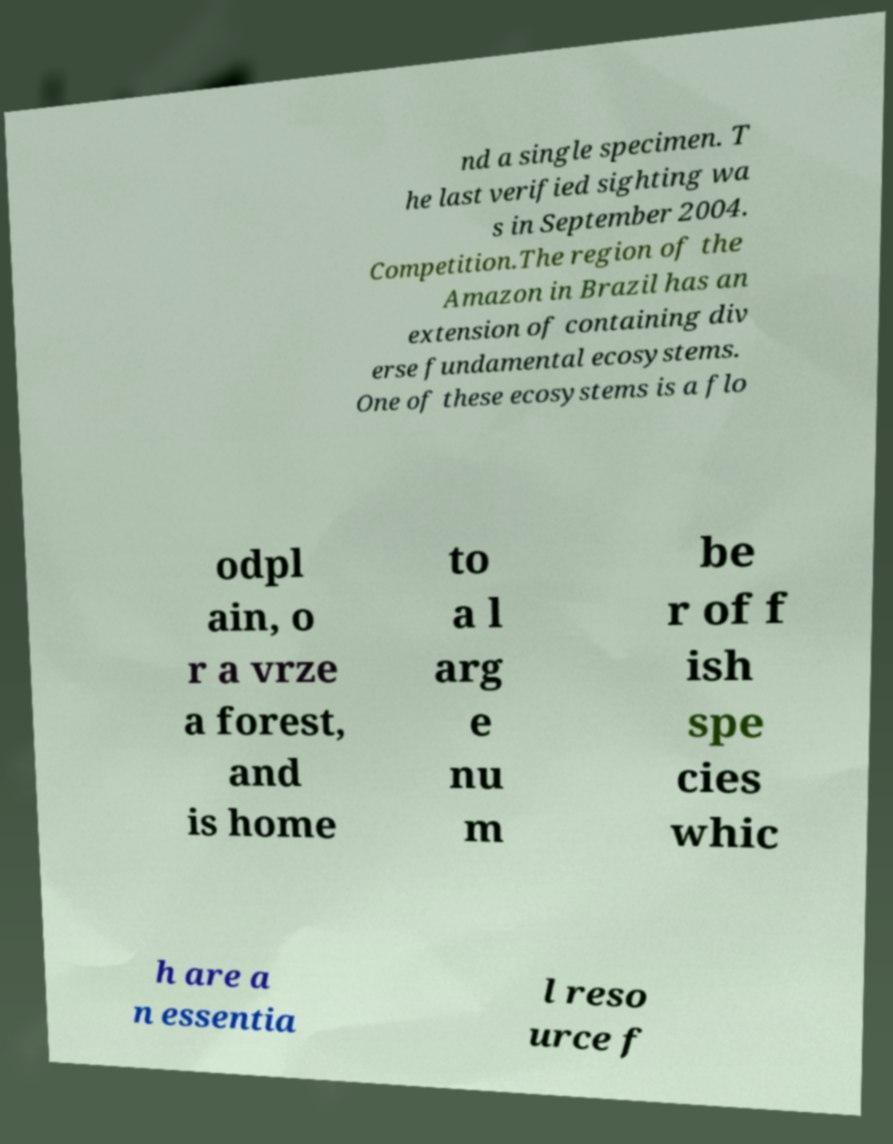Could you assist in decoding the text presented in this image and type it out clearly? nd a single specimen. T he last verified sighting wa s in September 2004. Competition.The region of the Amazon in Brazil has an extension of containing div erse fundamental ecosystems. One of these ecosystems is a flo odpl ain, o r a vrze a forest, and is home to a l arg e nu m be r of f ish spe cies whic h are a n essentia l reso urce f 